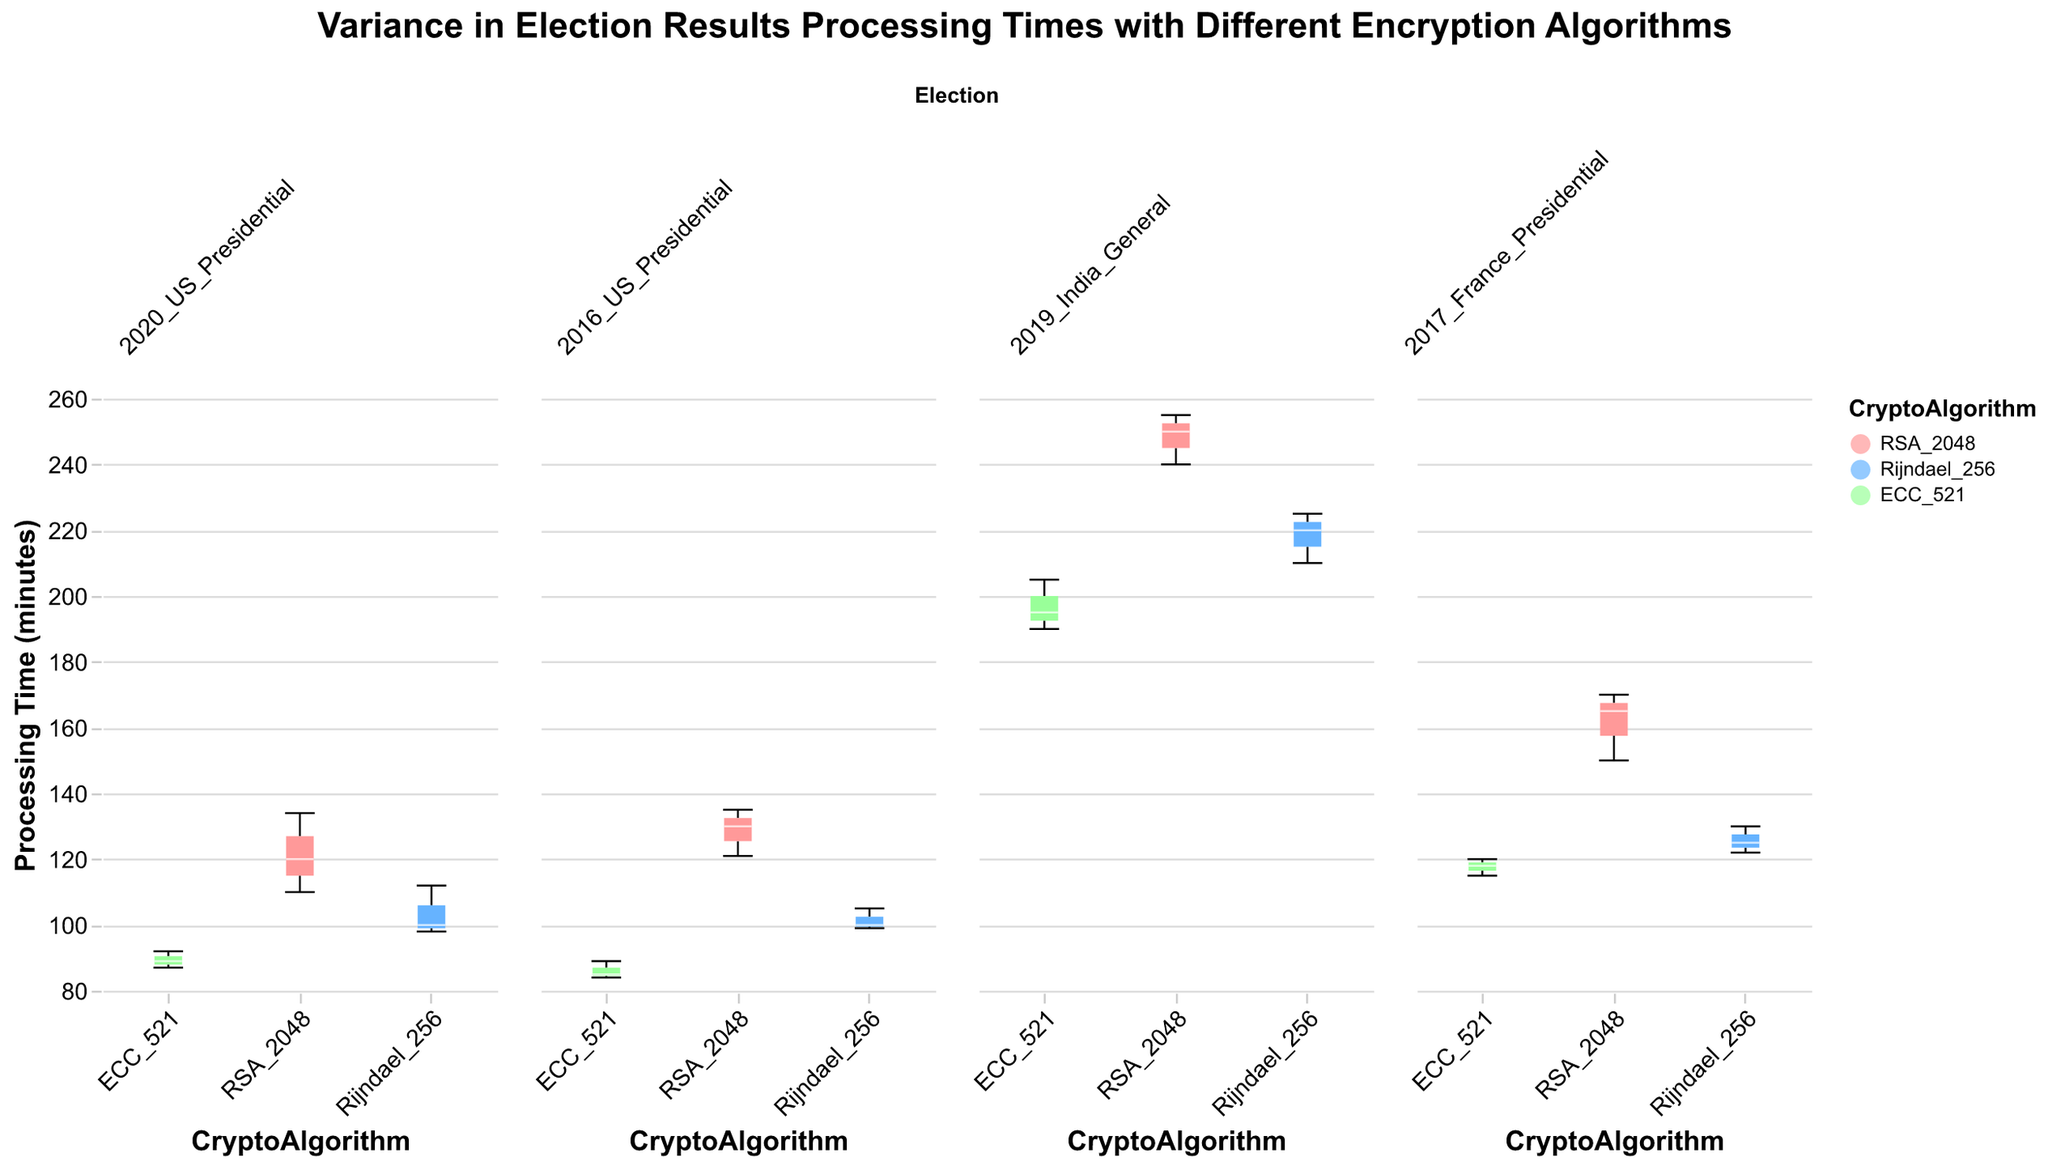What's the title of the figure? The title of the figure is displayed at the top center and reads "Variance in Election Results Processing Times with Different Encryption Algorithms".
Answer: Variance in Election Results Processing Times with Different Encryption Algorithms Which encryption algorithm has the lowest processing time in the 2020 US Presidential election? By looking at the box plots for the 2020 US Presidential election subplot, the ECC_521 algorithm has the lowest processing time, with a minimum below 90 minutes.
Answer: ECC_521 Which election has the highest median processing time for the RSA_2048 encryption algorithm? By observing the medians in the box plots, the 2019 India General election has the highest median processing time for the RSA_2048 algorithm, around 240 minutes.
Answer: 2019 India General Compare the variability in processing times for Rijndael_256 in the 2017 France Presidential and 2019 India General elections. Which has more variability? The variability is indicated by the range of the box plots. Rijndael_256 in the 2019 India General election has a larger range (from 210 to 225 minutes) compared to the 2017 France Presidential election (from 122 to 130 minutes).
Answer: 2019 India General What is the median processing time for ECC_521 in the 2020 US Presidential election? The median is represented by the white line in the box plot for ECC_521 in the 2020 US Presidential election, which is around 89 minutes.
Answer: 89 minutes How does the range of processing times for RSA_2048 in the 2016 US Presidential election compare to its range in the 2017 France Presidential election? Comparing the ranges, RSA_2048 in the 2016 US Presidential election varies from approximately 121 to 135 minutes, while in the 2017 France Presidential election, it ranges from around 150 to 170 minutes. This indicates a broader range in the 2017 France Presidential election.
Answer: 2017 France Presidential What information does the y-axis provide? The y-axis provides the processing time in minutes, which indicates the duration taken to process election results with different encryption algorithms.
Answer: Processing time in minutes How does the median processing time for Rijndael_256 in the 2016 US Presidential election compare to that in the 2020 US Presidential election? The medians are noted by the white lines in the box plots. In the 2016 US Presidential election, the median is approximately 100 minutes, while in the 2020 US Presidential election, it is around 100 minutes as well.
Answer: Approx equal 